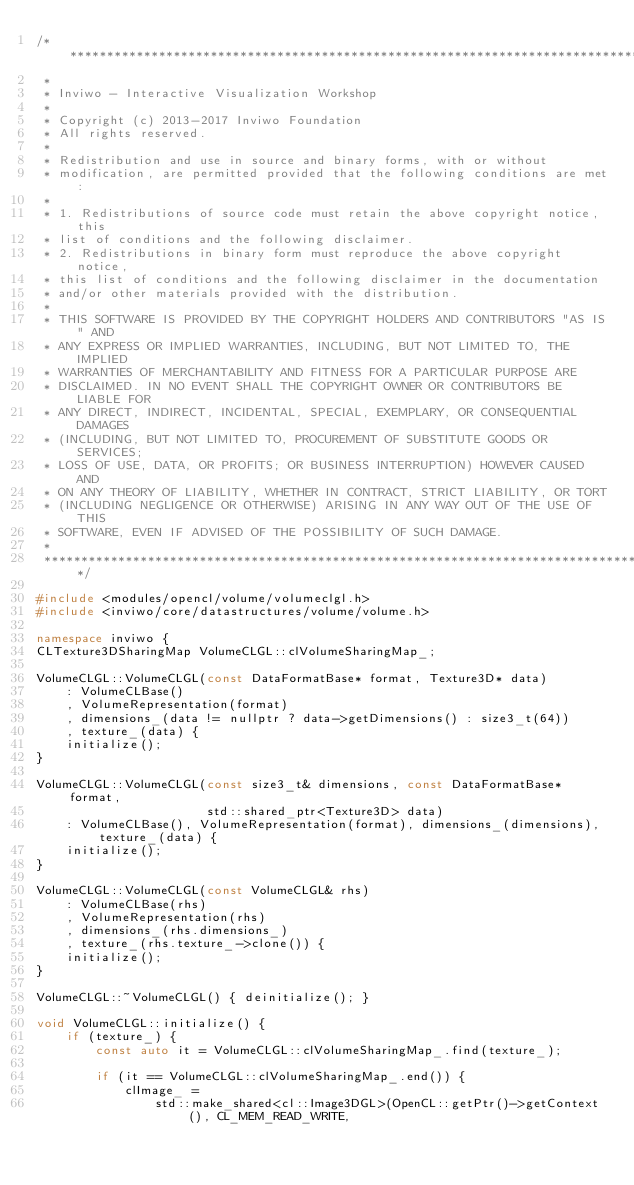<code> <loc_0><loc_0><loc_500><loc_500><_C++_>/*********************************************************************************
 *
 * Inviwo - Interactive Visualization Workshop
 *
 * Copyright (c) 2013-2017 Inviwo Foundation
 * All rights reserved.
 *
 * Redistribution and use in source and binary forms, with or without
 * modification, are permitted provided that the following conditions are met:
 *
 * 1. Redistributions of source code must retain the above copyright notice, this
 * list of conditions and the following disclaimer.
 * 2. Redistributions in binary form must reproduce the above copyright notice,
 * this list of conditions and the following disclaimer in the documentation
 * and/or other materials provided with the distribution.
 *
 * THIS SOFTWARE IS PROVIDED BY THE COPYRIGHT HOLDERS AND CONTRIBUTORS "AS IS" AND
 * ANY EXPRESS OR IMPLIED WARRANTIES, INCLUDING, BUT NOT LIMITED TO, THE IMPLIED
 * WARRANTIES OF MERCHANTABILITY AND FITNESS FOR A PARTICULAR PURPOSE ARE
 * DISCLAIMED. IN NO EVENT SHALL THE COPYRIGHT OWNER OR CONTRIBUTORS BE LIABLE FOR
 * ANY DIRECT, INDIRECT, INCIDENTAL, SPECIAL, EXEMPLARY, OR CONSEQUENTIAL DAMAGES
 * (INCLUDING, BUT NOT LIMITED TO, PROCUREMENT OF SUBSTITUTE GOODS OR SERVICES;
 * LOSS OF USE, DATA, OR PROFITS; OR BUSINESS INTERRUPTION) HOWEVER CAUSED AND
 * ON ANY THEORY OF LIABILITY, WHETHER IN CONTRACT, STRICT LIABILITY, OR TORT
 * (INCLUDING NEGLIGENCE OR OTHERWISE) ARISING IN ANY WAY OUT OF THE USE OF THIS
 * SOFTWARE, EVEN IF ADVISED OF THE POSSIBILITY OF SUCH DAMAGE.
 *
 *********************************************************************************/

#include <modules/opencl/volume/volumeclgl.h>
#include <inviwo/core/datastructures/volume/volume.h>

namespace inviwo {
CLTexture3DSharingMap VolumeCLGL::clVolumeSharingMap_;

VolumeCLGL::VolumeCLGL(const DataFormatBase* format, Texture3D* data)
    : VolumeCLBase()
    , VolumeRepresentation(format)
    , dimensions_(data != nullptr ? data->getDimensions() : size3_t(64))
    , texture_(data) {
    initialize();
}

VolumeCLGL::VolumeCLGL(const size3_t& dimensions, const DataFormatBase* format,
                       std::shared_ptr<Texture3D> data)
    : VolumeCLBase(), VolumeRepresentation(format), dimensions_(dimensions), texture_(data) {
    initialize();
}

VolumeCLGL::VolumeCLGL(const VolumeCLGL& rhs)
    : VolumeCLBase(rhs)
    , VolumeRepresentation(rhs)
    , dimensions_(rhs.dimensions_)
    , texture_(rhs.texture_->clone()) {
    initialize();
}

VolumeCLGL::~VolumeCLGL() { deinitialize(); }

void VolumeCLGL::initialize() {
    if (texture_) {
        const auto it = VolumeCLGL::clVolumeSharingMap_.find(texture_);

        if (it == VolumeCLGL::clVolumeSharingMap_.end()) {
            clImage_ =
                std::make_shared<cl::Image3DGL>(OpenCL::getPtr()->getContext(), CL_MEM_READ_WRITE,</code> 